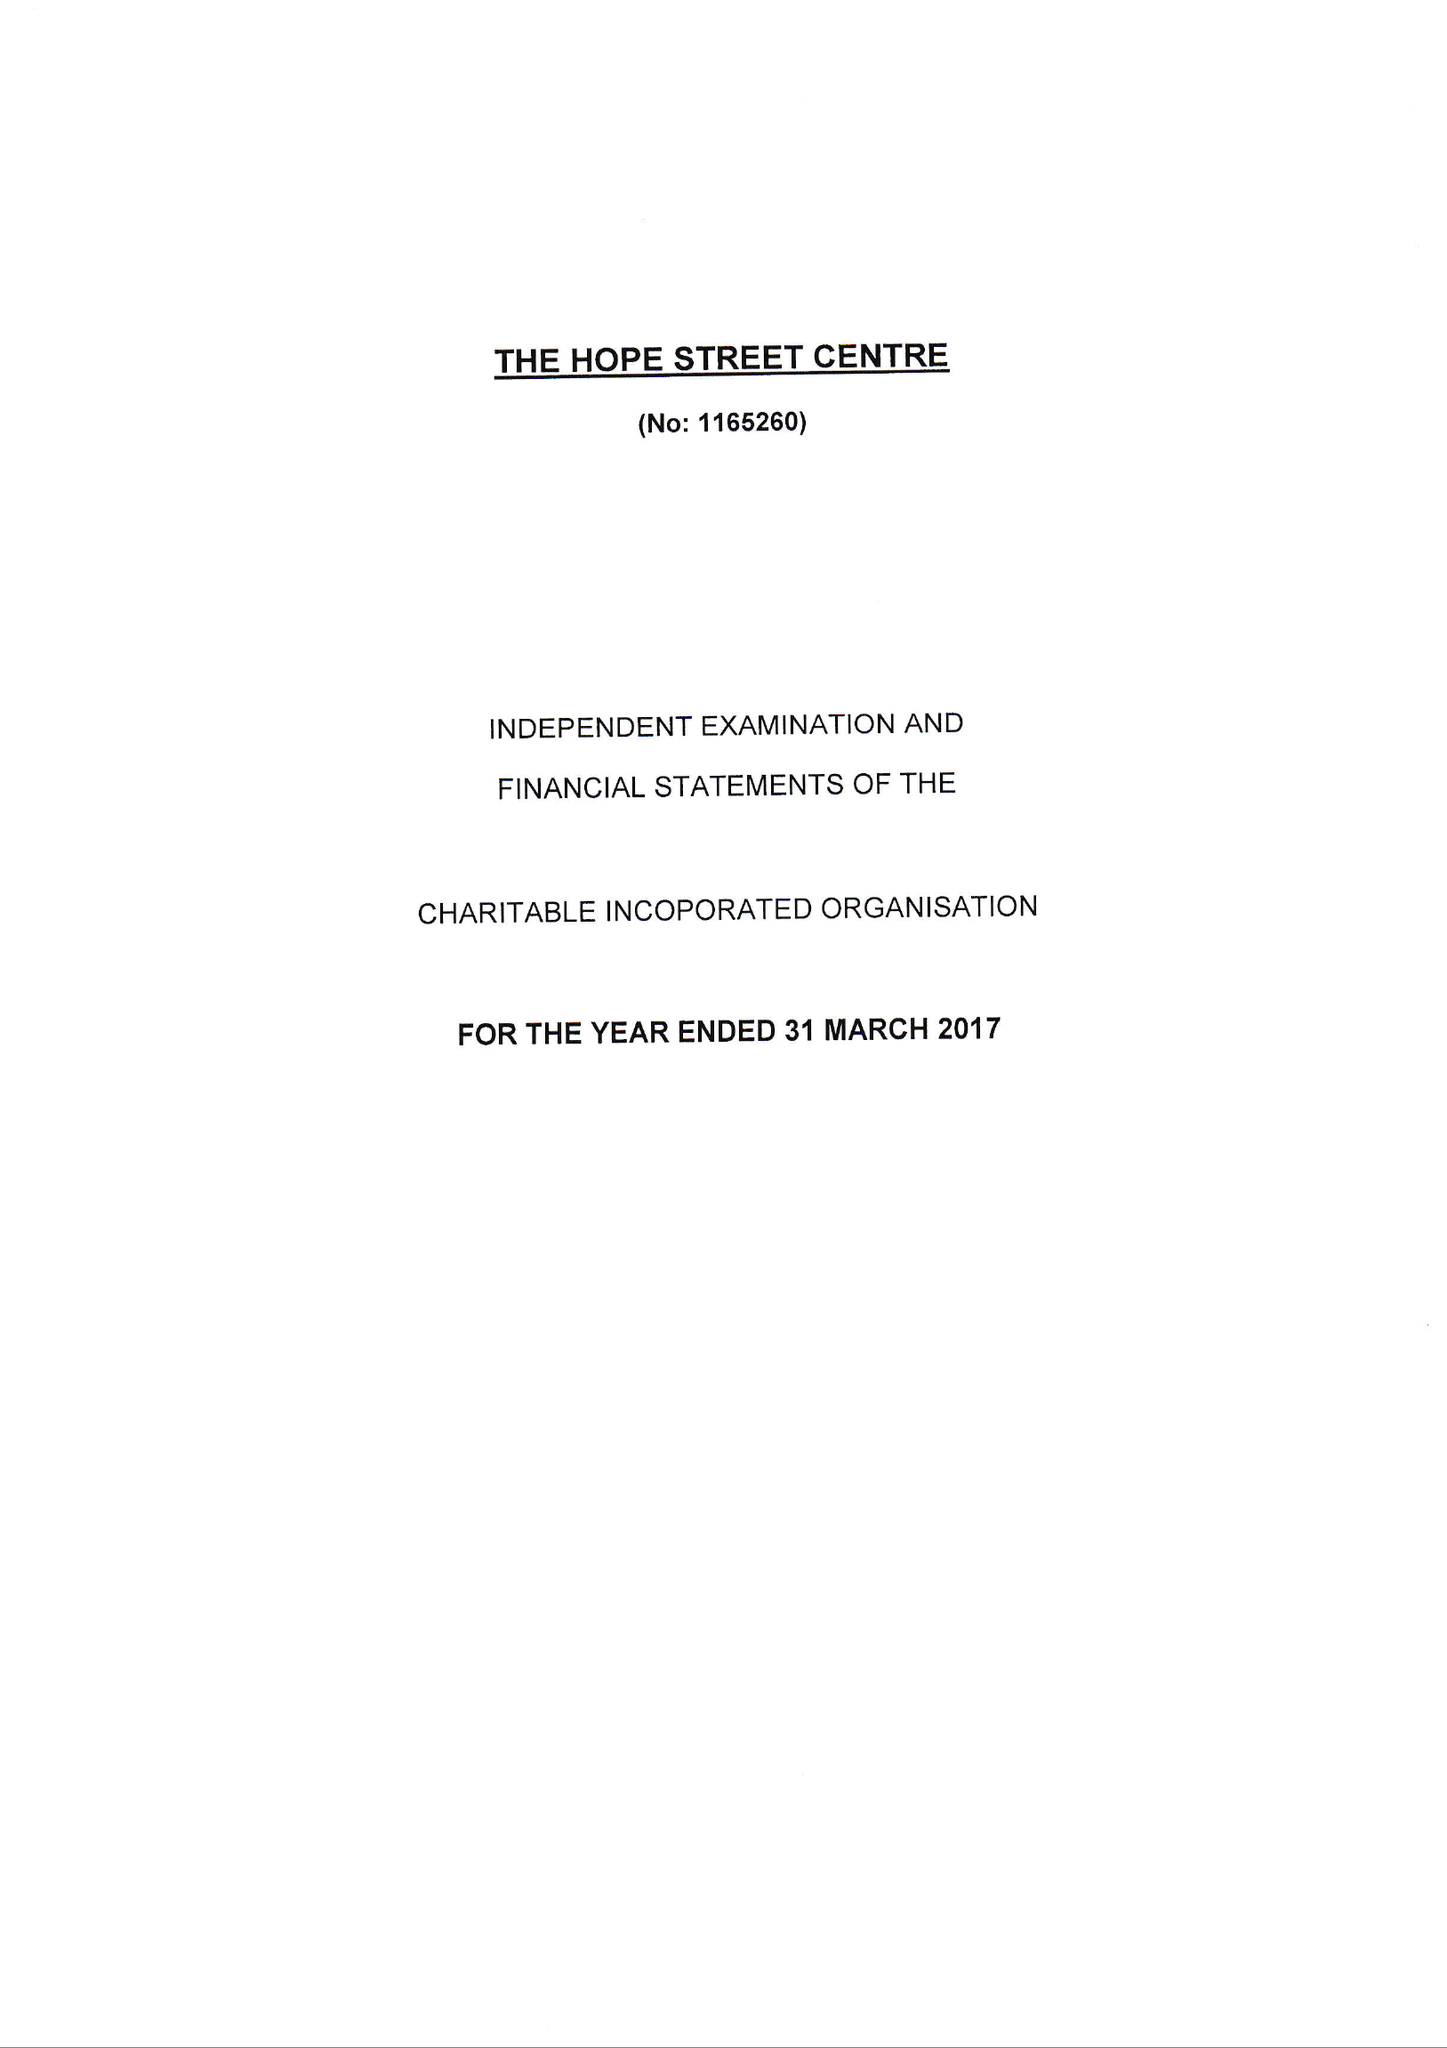What is the value for the charity_number?
Answer the question using a single word or phrase. 1165260 